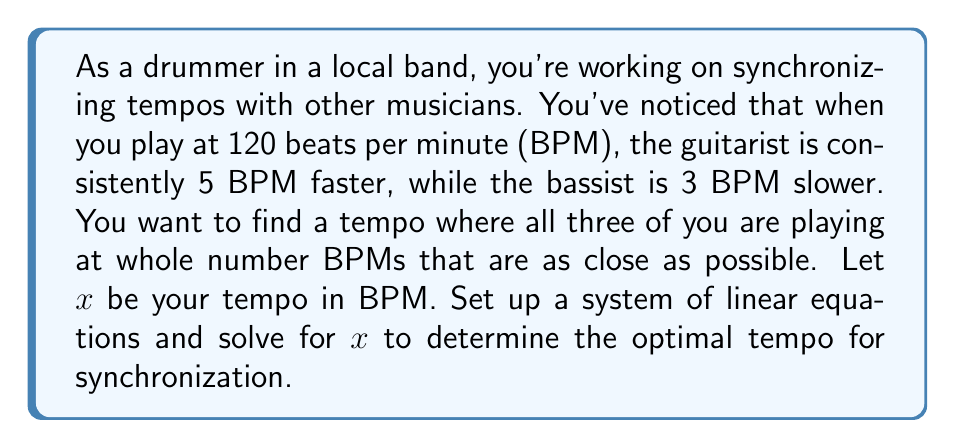Solve this math problem. Let's approach this step-by-step:

1) First, let's set up our equations based on the given information:
   Your tempo: $x$ BPM
   Guitarist's tempo: $x + 5$ BPM
   Bassist's tempo: $x - 3$ BPM

2) We want all tempos to be whole numbers, so we can set up the following system of equations:
   $$\begin{cases}
   x = n \\
   x + 5 = m \\
   x - 3 = p
   \end{cases}$$
   where $n$, $m$, and $p$ are integers.

3) From the second equation: $m = x + 5$
   From the third equation: $p = x - 3$

4) The difference between $m$ and $p$ should be 8:
   $m - p = (x + 5) - (x - 3) = 8$

5) To find the optimal tempo, we want $x$ to be as close as possible to 120 BPM while satisfying these conditions.

6) Let's try values close to 120:
   If $x = 119$:
   Guitarist: 124 BPM
   Bassist: 116 BPM
   This works!

7) We can verify that this is the closest solution to 120 BPM:
   If $x = 120$, the bassist would be at 117 BPM (not a whole number).
   If $x = 118$, the guitarist would be at 123 BPM (not following the 8 BPM difference).

Therefore, the optimal tempo for synchronization is 119 BPM.
Answer: The optimal tempo for synchronization is 119 BPM. 